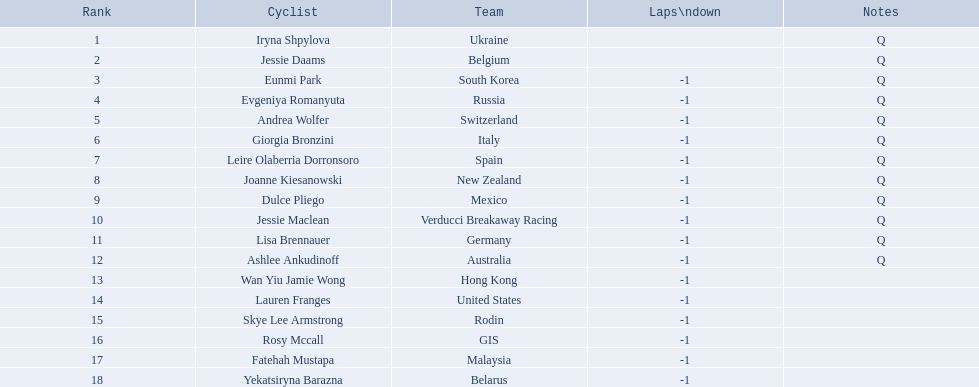Who are all the bike riders participating in this competition? Iryna Shpylova, Jessie Daams, Eunmi Park, Evgeniya Romanyuta, Andrea Wolfer, Giorgia Bronzini, Leire Olaberria Dorronsoro, Joanne Kiesanowski, Dulce Pliego, Jessie Maclean, Lisa Brennauer, Ashlee Ankudinoff, Wan Yiu Jamie Wong, Lauren Franges, Skye Lee Armstrong, Rosy Mccall, Fatehah Mustapa, Yekatsiryna Barazna. Among them, who has the smallest numbered position? Iryna Shpylova. 